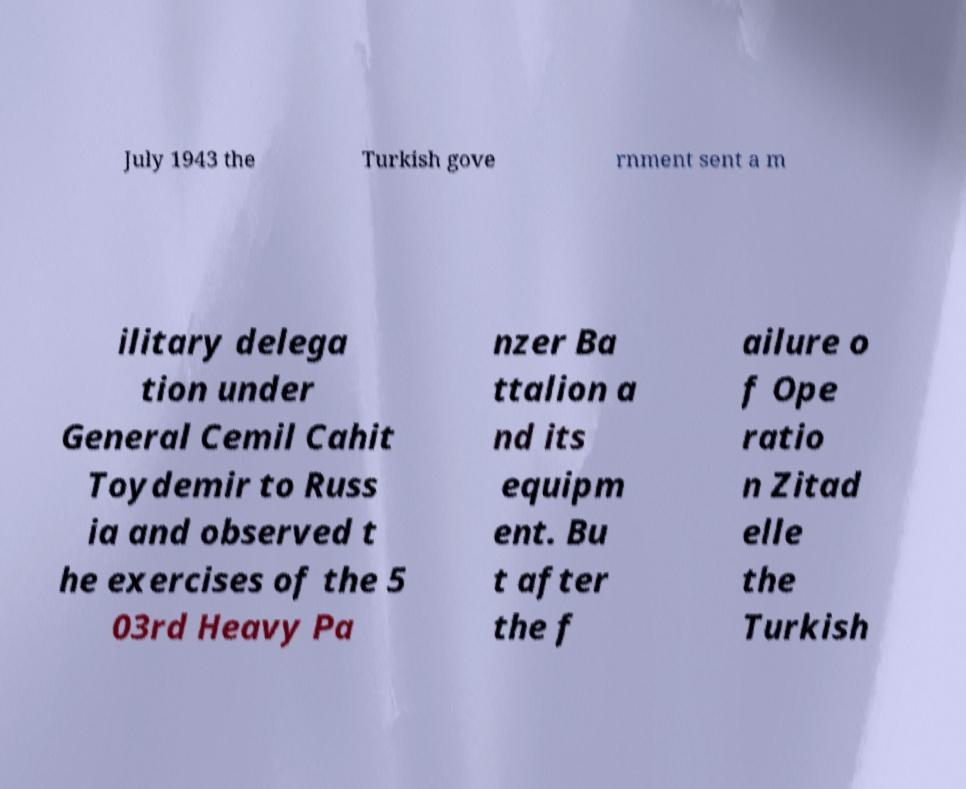Could you assist in decoding the text presented in this image and type it out clearly? July 1943 the Turkish gove rnment sent a m ilitary delega tion under General Cemil Cahit Toydemir to Russ ia and observed t he exercises of the 5 03rd Heavy Pa nzer Ba ttalion a nd its equipm ent. Bu t after the f ailure o f Ope ratio n Zitad elle the Turkish 